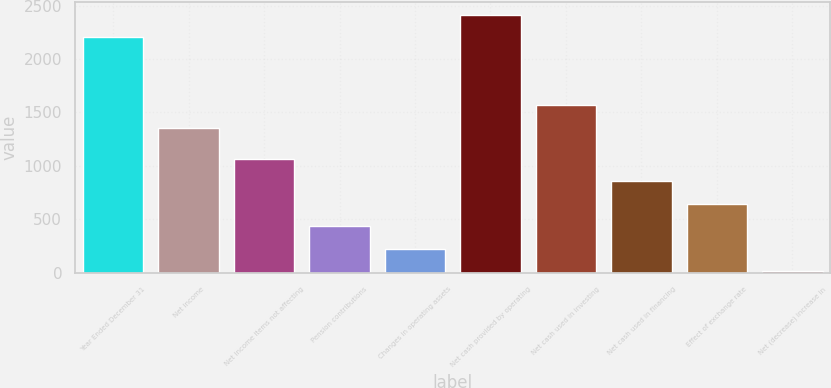Convert chart to OTSL. <chart><loc_0><loc_0><loc_500><loc_500><bar_chart><fcel>Year Ended December 31<fcel>Net income<fcel>Net income items not affecting<fcel>Pension contributions<fcel>Changes in operating assets<fcel>Net cash provided by operating<fcel>Net cash used in investing<fcel>Net cash used in financing<fcel>Effect of exchange rate<fcel>Net (decrease) increase in<nl><fcel>2203.24<fcel>1358.8<fcel>1068.05<fcel>434.72<fcel>223.61<fcel>2414.35<fcel>1569.91<fcel>856.94<fcel>645.83<fcel>12.5<nl></chart> 